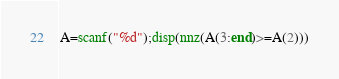<code> <loc_0><loc_0><loc_500><loc_500><_Octave_>A=scanf("%d");disp(nnz(A(3:end)>=A(2)))</code> 